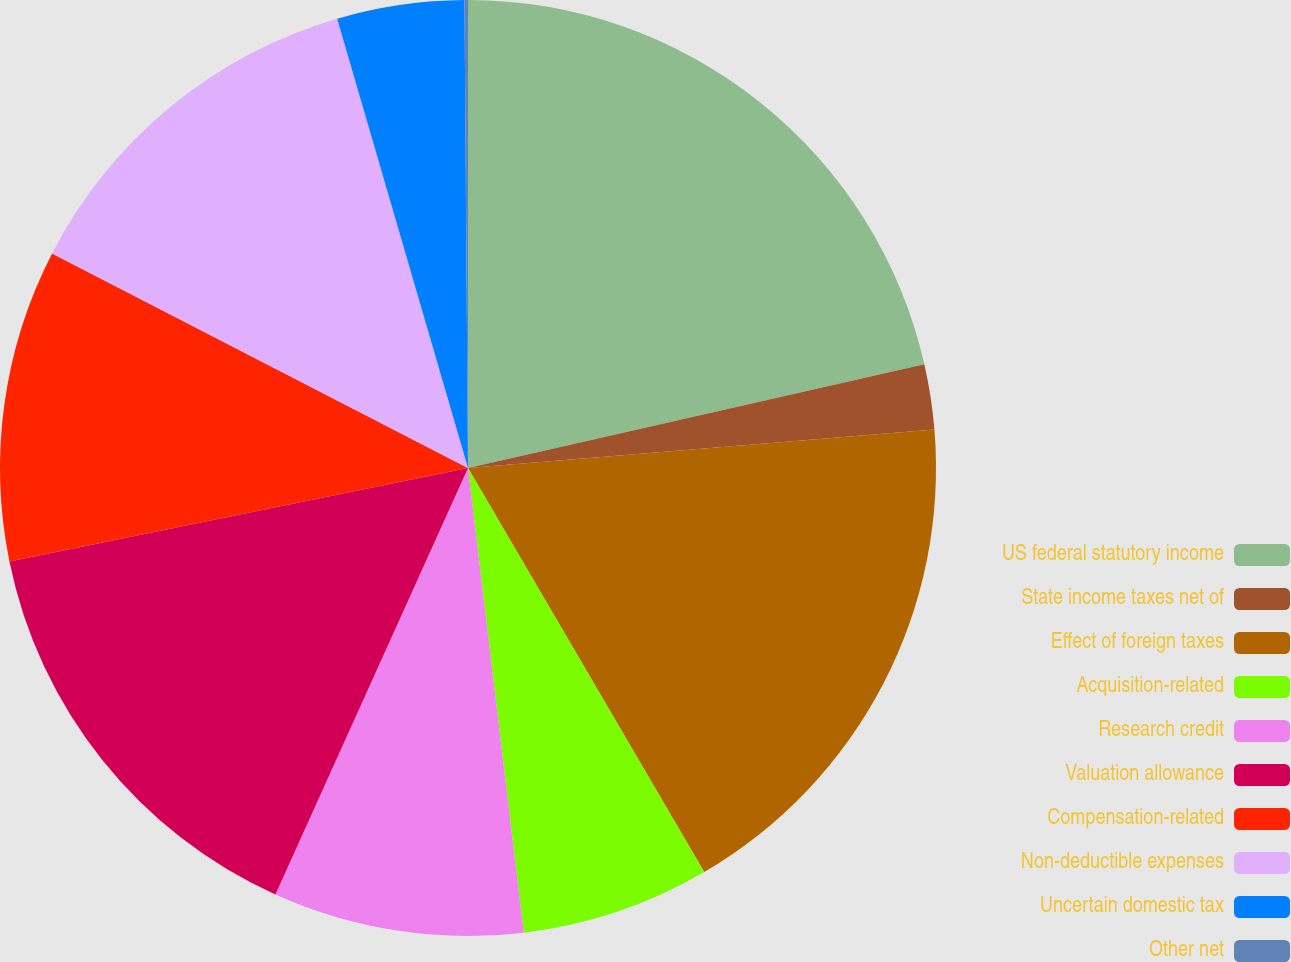<chart> <loc_0><loc_0><loc_500><loc_500><pie_chart><fcel>US federal statutory income<fcel>State income taxes net of<fcel>Effect of foreign taxes<fcel>Acquisition-related<fcel>Research credit<fcel>Valuation allowance<fcel>Compensation-related<fcel>Non-deductible expenses<fcel>Uncertain domestic tax<fcel>Other net<nl><fcel>21.44%<fcel>2.25%<fcel>17.89%<fcel>6.52%<fcel>8.65%<fcel>15.05%<fcel>10.78%<fcel>12.91%<fcel>4.39%<fcel>0.12%<nl></chart> 